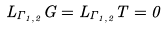Convert formula to latex. <formula><loc_0><loc_0><loc_500><loc_500>L _ { \Gamma _ { 1 , 2 } } G = L _ { \Gamma _ { 1 , 2 } } T = 0</formula> 